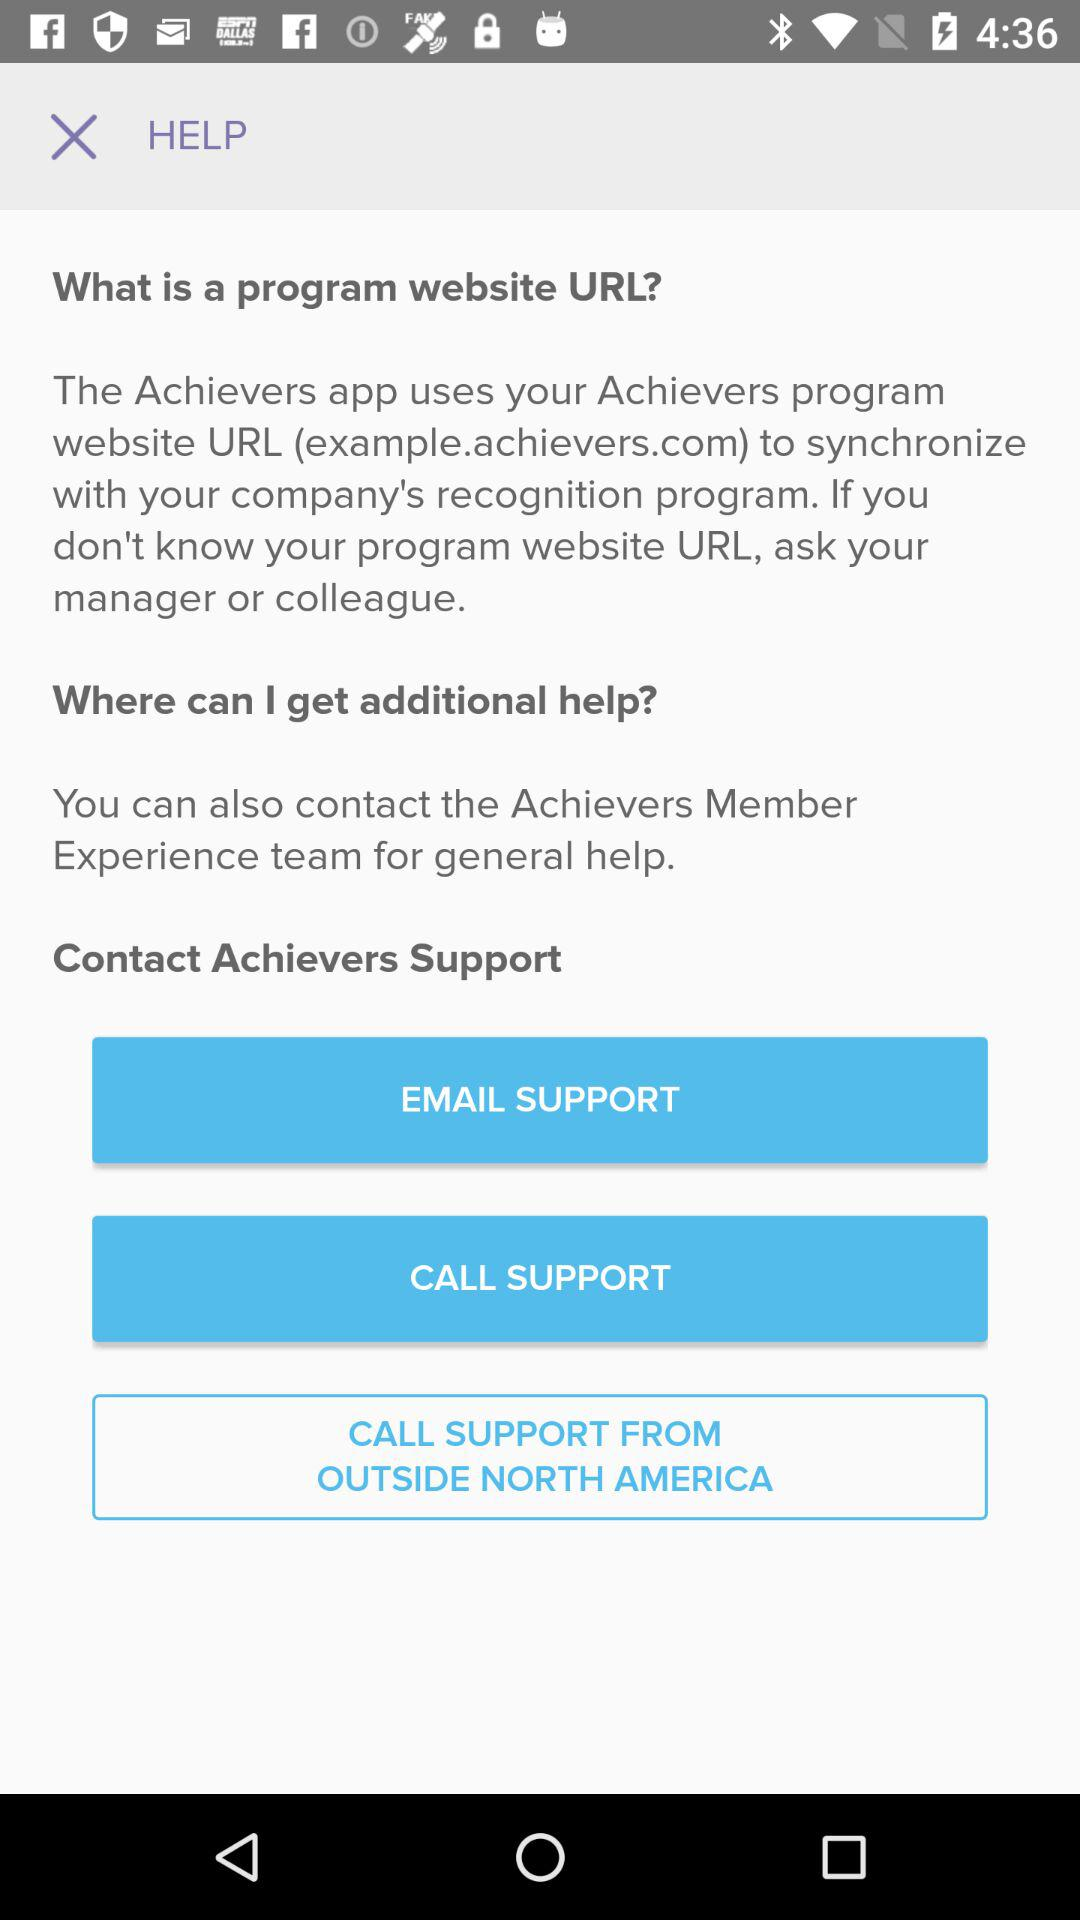What are the different ways to contact Achievers' support? The different ways are "EMAIL" AND "CALL". 